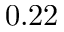Convert formula to latex. <formula><loc_0><loc_0><loc_500><loc_500>0 . 2 2</formula> 